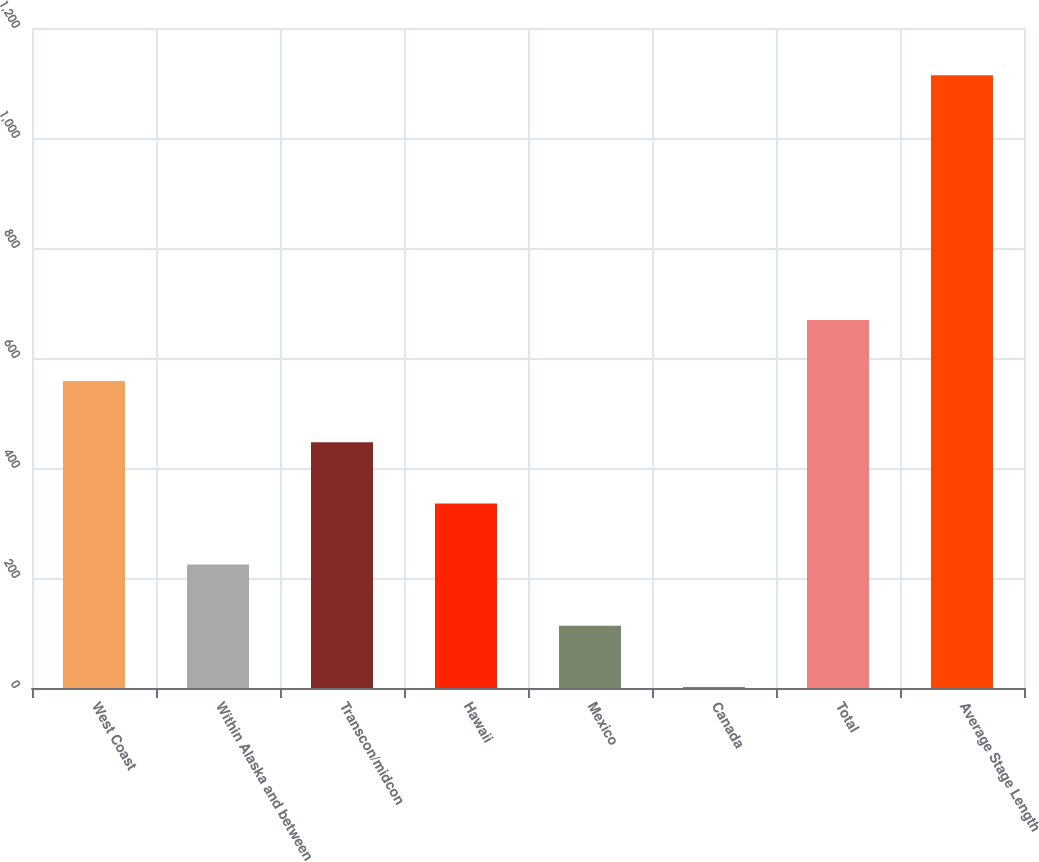Convert chart. <chart><loc_0><loc_0><loc_500><loc_500><bar_chart><fcel>West Coast<fcel>Within Alaska and between<fcel>Transcon/midcon<fcel>Hawaii<fcel>Mexico<fcel>Canada<fcel>Total<fcel>Average Stage Length<nl><fcel>558<fcel>224.4<fcel>446.8<fcel>335.6<fcel>113.2<fcel>2<fcel>669.2<fcel>1114<nl></chart> 